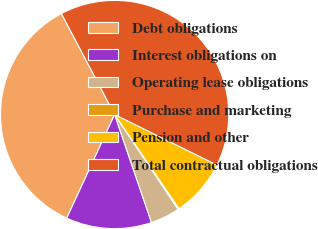<chart> <loc_0><loc_0><loc_500><loc_500><pie_chart><fcel>Debt obligations<fcel>Interest obligations on<fcel>Operating lease obligations<fcel>Purchase and marketing<fcel>Pension and other<fcel>Total contractual obligations<nl><fcel>35.39%<fcel>12.12%<fcel>4.15%<fcel>0.17%<fcel>8.14%<fcel>40.02%<nl></chart> 